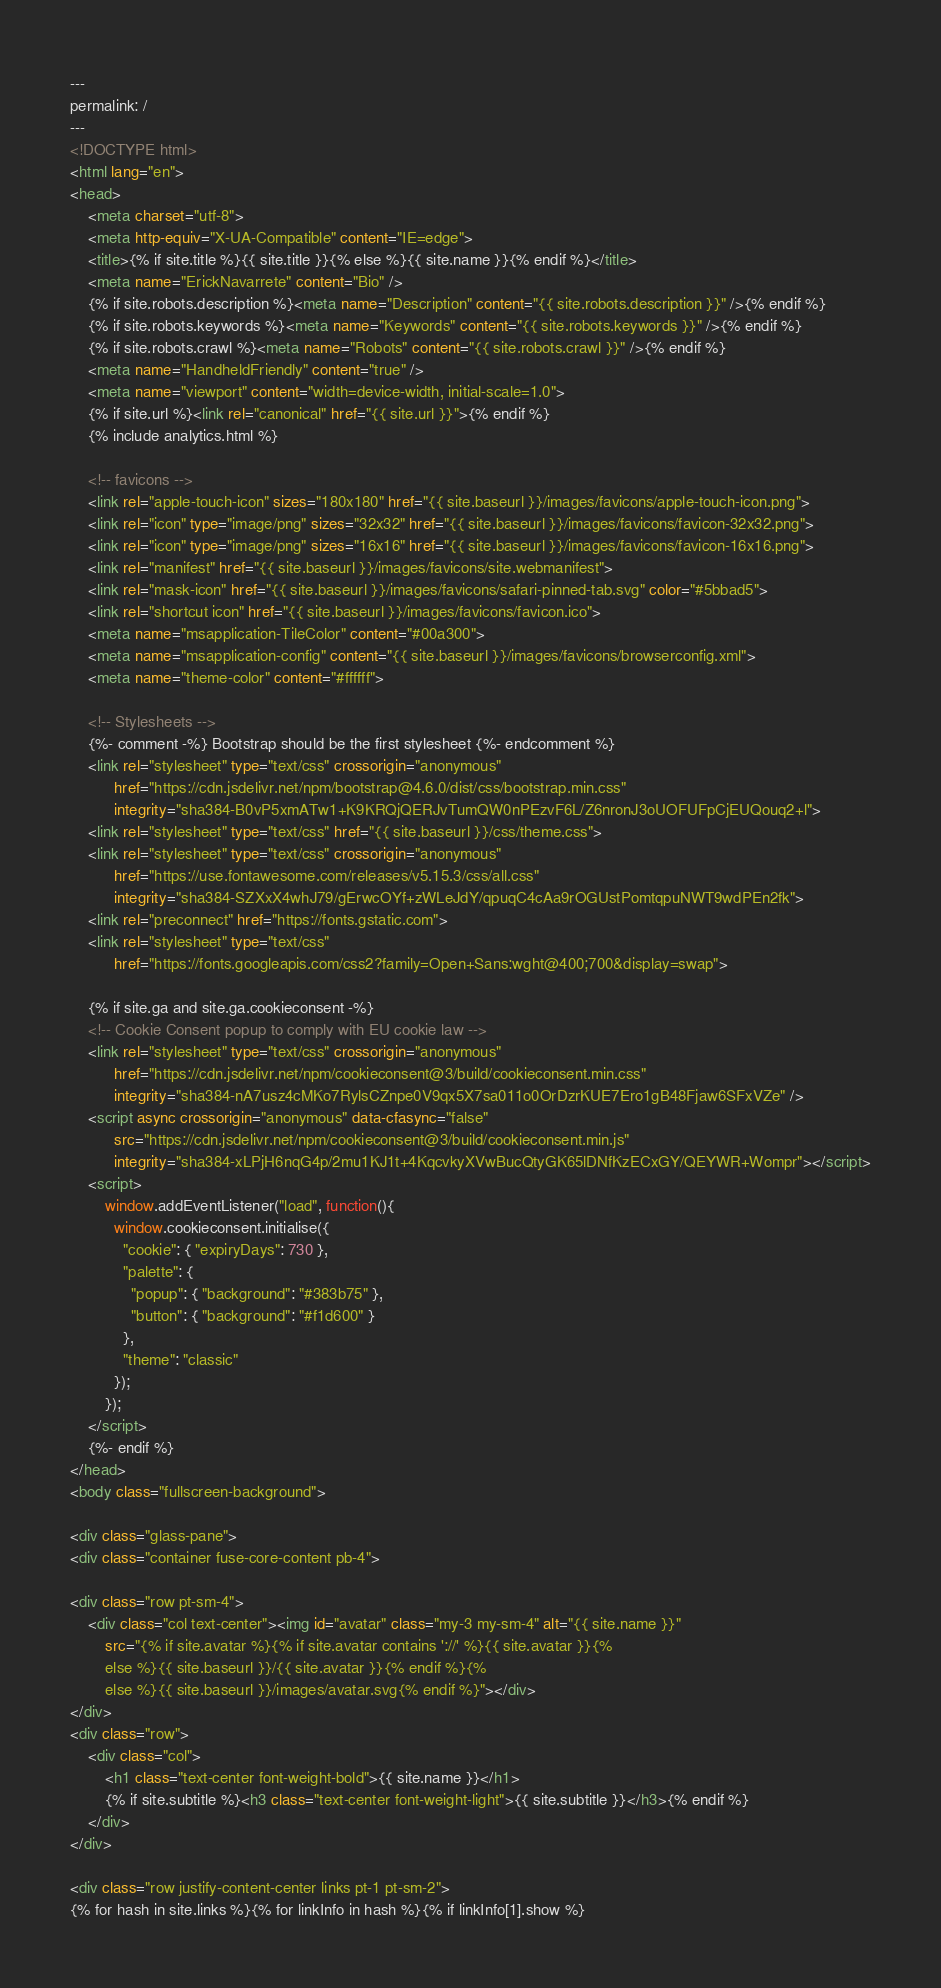<code> <loc_0><loc_0><loc_500><loc_500><_HTML_>---
permalink: /
---
<!DOCTYPE html>
<html lang="en">
<head>
    <meta charset="utf-8">
    <meta http-equiv="X-UA-Compatible" content="IE=edge">
    <title>{% if site.title %}{{ site.title }}{% else %}{{ site.name }}{% endif %}</title>
    <meta name="ErickNavarrete" content="Bio" />
    {% if site.robots.description %}<meta name="Description" content="{{ site.robots.description }}" />{% endif %}
    {% if site.robots.keywords %}<meta name="Keywords" content="{{ site.robots.keywords }}" />{% endif %}
    {% if site.robots.crawl %}<meta name="Robots" content="{{ site.robots.crawl }}" />{% endif %}
    <meta name="HandheldFriendly" content="true" />
    <meta name="viewport" content="width=device-width, initial-scale=1.0">
    {% if site.url %}<link rel="canonical" href="{{ site.url }}">{% endif %}
    {% include analytics.html %}

    <!-- favicons -->
    <link rel="apple-touch-icon" sizes="180x180" href="{{ site.baseurl }}/images/favicons/apple-touch-icon.png">
    <link rel="icon" type="image/png" sizes="32x32" href="{{ site.baseurl }}/images/favicons/favicon-32x32.png">
    <link rel="icon" type="image/png" sizes="16x16" href="{{ site.baseurl }}/images/favicons/favicon-16x16.png">
    <link rel="manifest" href="{{ site.baseurl }}/images/favicons/site.webmanifest">
    <link rel="mask-icon" href="{{ site.baseurl }}/images/favicons/safari-pinned-tab.svg" color="#5bbad5">
    <link rel="shortcut icon" href="{{ site.baseurl }}/images/favicons/favicon.ico">
    <meta name="msapplication-TileColor" content="#00a300">
    <meta name="msapplication-config" content="{{ site.baseurl }}/images/favicons/browserconfig.xml">
    <meta name="theme-color" content="#ffffff">

    <!-- Stylesheets -->
    {%- comment -%} Bootstrap should be the first stylesheet {%- endcomment %}
    <link rel="stylesheet" type="text/css" crossorigin="anonymous"
          href="https://cdn.jsdelivr.net/npm/bootstrap@4.6.0/dist/css/bootstrap.min.css"
          integrity="sha384-B0vP5xmATw1+K9KRQjQERJvTumQW0nPEzvF6L/Z6nronJ3oUOFUFpCjEUQouq2+l">
    <link rel="stylesheet" type="text/css" href="{{ site.baseurl }}/css/theme.css">
    <link rel="stylesheet" type="text/css" crossorigin="anonymous"
          href="https://use.fontawesome.com/releases/v5.15.3/css/all.css"
          integrity="sha384-SZXxX4whJ79/gErwcOYf+zWLeJdY/qpuqC4cAa9rOGUstPomtqpuNWT9wdPEn2fk">
    <link rel="preconnect" href="https://fonts.gstatic.com">
    <link rel="stylesheet" type="text/css"
          href="https://fonts.googleapis.com/css2?family=Open+Sans:wght@400;700&display=swap"> 

    {% if site.ga and site.ga.cookieconsent -%}
    <!-- Cookie Consent popup to comply with EU cookie law -->
    <link rel="stylesheet" type="text/css" crossorigin="anonymous"
          href="https://cdn.jsdelivr.net/npm/cookieconsent@3/build/cookieconsent.min.css"
          integrity="sha384-nA7usz4cMKo7RylsCZnpe0V9qx5X7sa011o0OrDzrKUE7Ero1gB48Fjaw6SFxVZe" />
    <script async crossorigin="anonymous" data-cfasync="false"
          src="https://cdn.jsdelivr.net/npm/cookieconsent@3/build/cookieconsent.min.js"
          integrity="sha384-xLPjH6nqG4p/2mu1KJ1t+4KqcvkyXVwBucQtyGK65lDNfKzECxGY/QEYWR+Wompr"></script>
    <script>
        window.addEventListener("load", function(){
          window.cookieconsent.initialise({
            "cookie": { "expiryDays": 730 },
            "palette": {
              "popup": { "background": "#383b75" },
              "button": { "background": "#f1d600" }
            },
            "theme": "classic"
          });
        });
    </script>
    {%- endif %}
</head>
<body class="fullscreen-background">

<div class="glass-pane">
<div class="container fuse-core-content pb-4">

<div class="row pt-sm-4">
    <div class="col text-center"><img id="avatar" class="my-3 my-sm-4" alt="{{ site.name }}"
        src="{% if site.avatar %}{% if site.avatar contains '://' %}{{ site.avatar }}{%
        else %}{{ site.baseurl }}/{{ site.avatar }}{% endif %}{%
        else %}{{ site.baseurl }}/images/avatar.svg{% endif %}"></div>
</div>
<div class="row">
    <div class="col">
        <h1 class="text-center font-weight-bold">{{ site.name }}</h1>
        {% if site.subtitle %}<h3 class="text-center font-weight-light">{{ site.subtitle }}</h3>{% endif %}
    </div>
</div>

<div class="row justify-content-center links pt-1 pt-sm-2">
{% for hash in site.links %}{% for linkInfo in hash %}{% if linkInfo[1].show %}</code> 